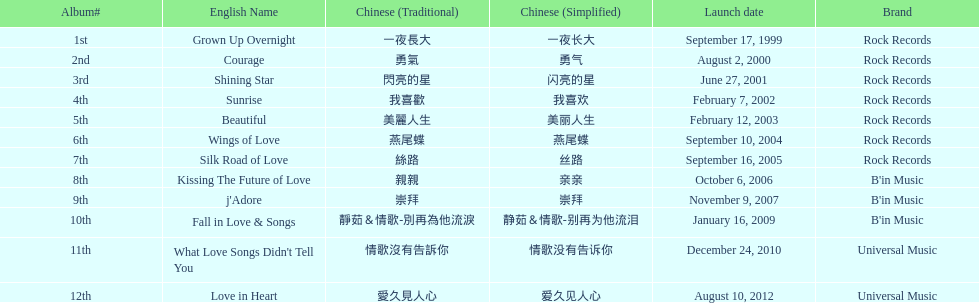What is the number of songs on rock records? 7. 